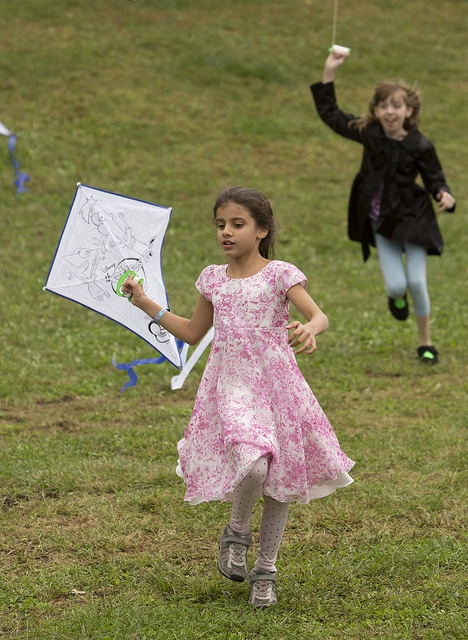Describe the objects in this image and their specific colors. I can see people in olive, lightpink, lightgray, darkgray, and gray tones, people in olive, black, gray, and darkgray tones, and kite in olive, lightgray, gray, and darkgray tones in this image. 